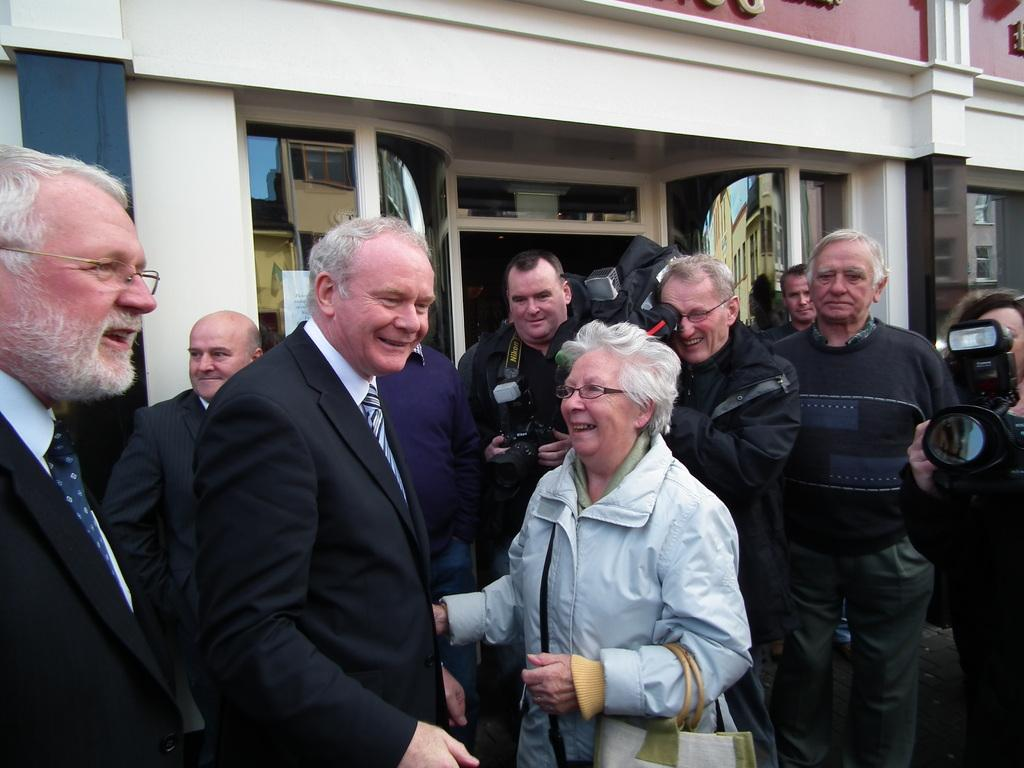How many people are in the image? There is a group of people in the image, but the exact number is not specified. What can be seen in the background of the image? There are buildings in the background of the image. How many sheep are visible in the image? There are no sheep present in the image. What type of cream is being used by the people in the image? There is no cream visible in the image, and the people's actions are not described. 